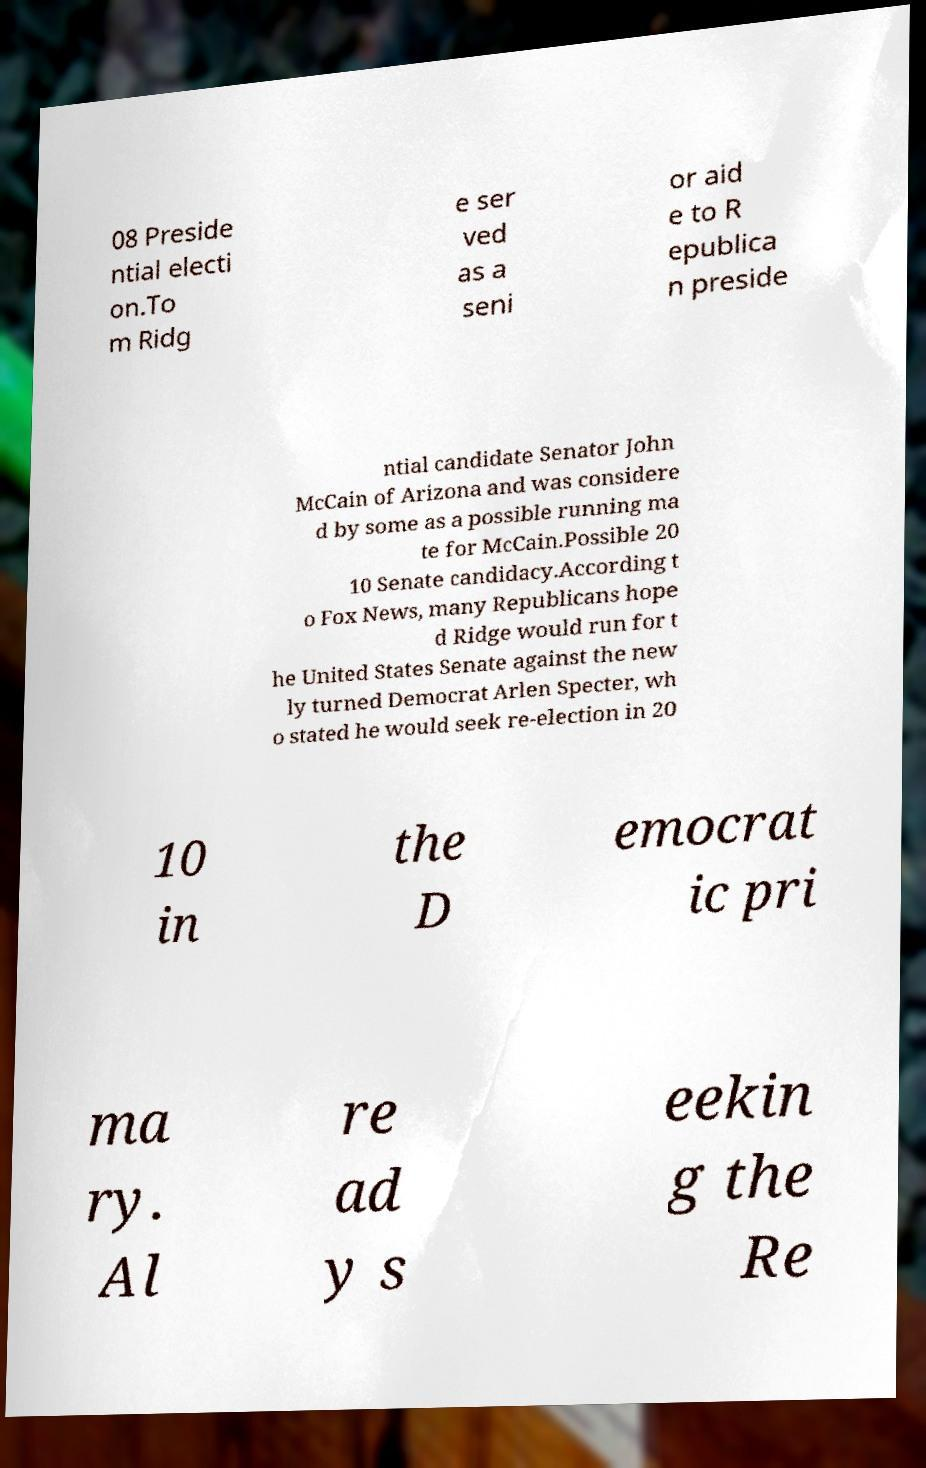Can you read and provide the text displayed in the image?This photo seems to have some interesting text. Can you extract and type it out for me? 08 Preside ntial electi on.To m Ridg e ser ved as a seni or aid e to R epublica n preside ntial candidate Senator John McCain of Arizona and was considere d by some as a possible running ma te for McCain.Possible 20 10 Senate candidacy.According t o Fox News, many Republicans hope d Ridge would run for t he United States Senate against the new ly turned Democrat Arlen Specter, wh o stated he would seek re-election in 20 10 in the D emocrat ic pri ma ry. Al re ad y s eekin g the Re 